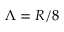<formula> <loc_0><loc_0><loc_500><loc_500>\Lambda = R / 8</formula> 